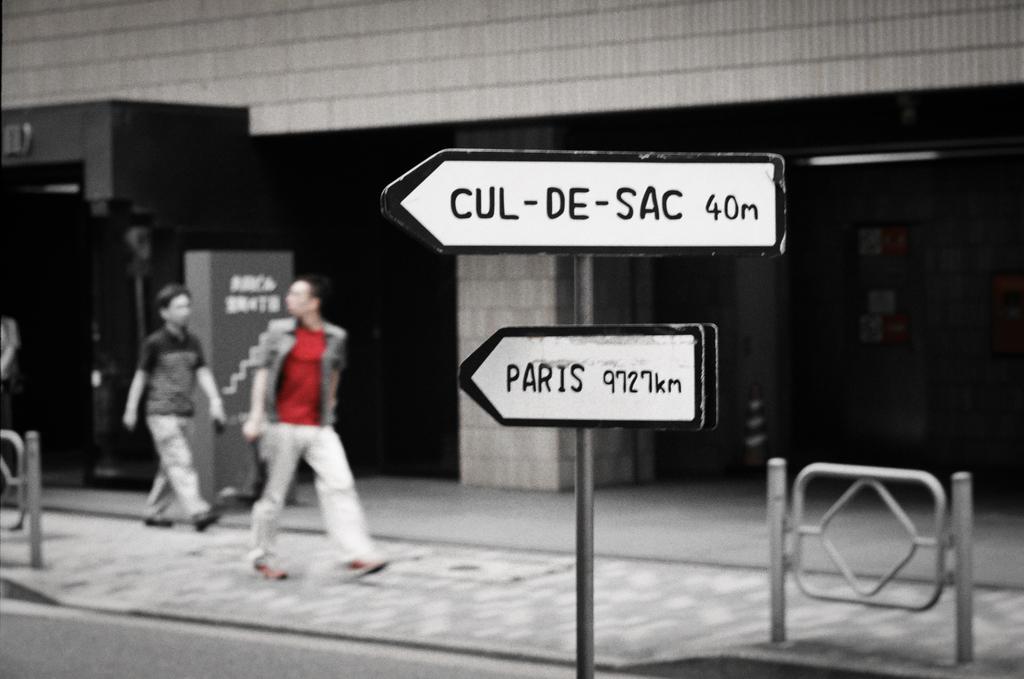Describe this image in one or two sentences. In this image I can see two people are walking and one person is wearing red and white dress. Back I can see a building and few sign boards. 